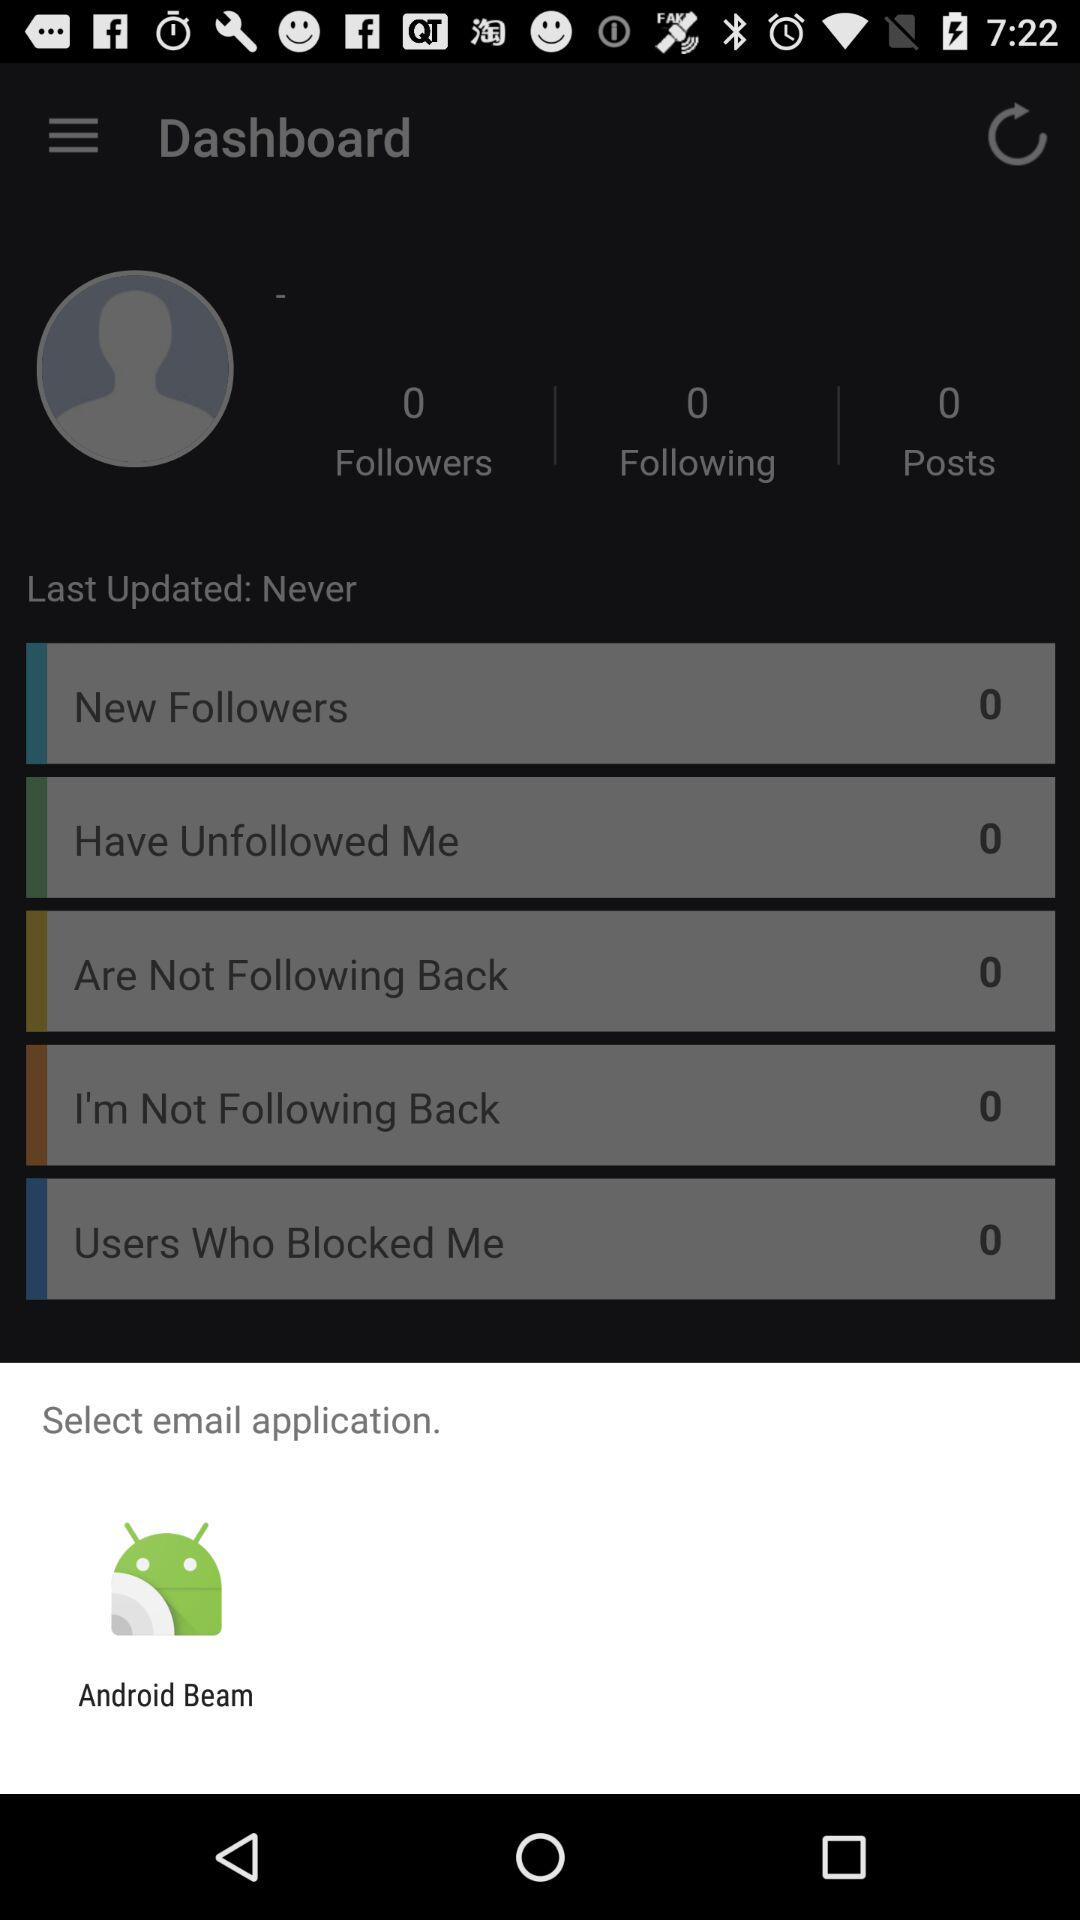What email application can be selected? The email application that can be selected is "Android Beam". 